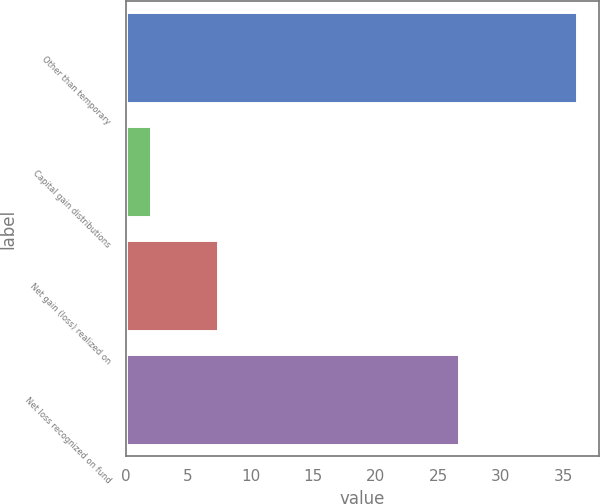Convert chart. <chart><loc_0><loc_0><loc_500><loc_500><bar_chart><fcel>Other than temporary<fcel>Capital gain distributions<fcel>Net gain (loss) realized on<fcel>Net loss recognized on fund<nl><fcel>36.1<fcel>2<fcel>7.4<fcel>26.7<nl></chart> 